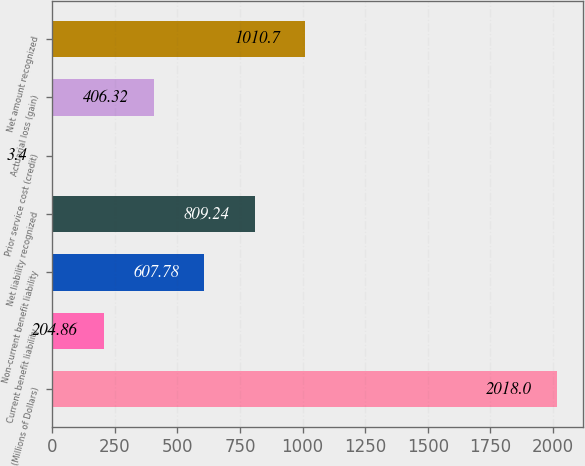<chart> <loc_0><loc_0><loc_500><loc_500><bar_chart><fcel>(Millions of Dollars)<fcel>Current benefit liability<fcel>Non-current benefit liability<fcel>Net liability recognized<fcel>Prior service cost (credit)<fcel>Actuarial loss (gain)<fcel>Net amount recognized<nl><fcel>2018<fcel>204.86<fcel>607.78<fcel>809.24<fcel>3.4<fcel>406.32<fcel>1010.7<nl></chart> 